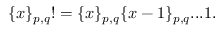<formula> <loc_0><loc_0><loc_500><loc_500>\{ x \} _ { p , q } ! = \{ x \} _ { p , q } \{ x - 1 \} _ { p , q } \dots 1 .</formula> 